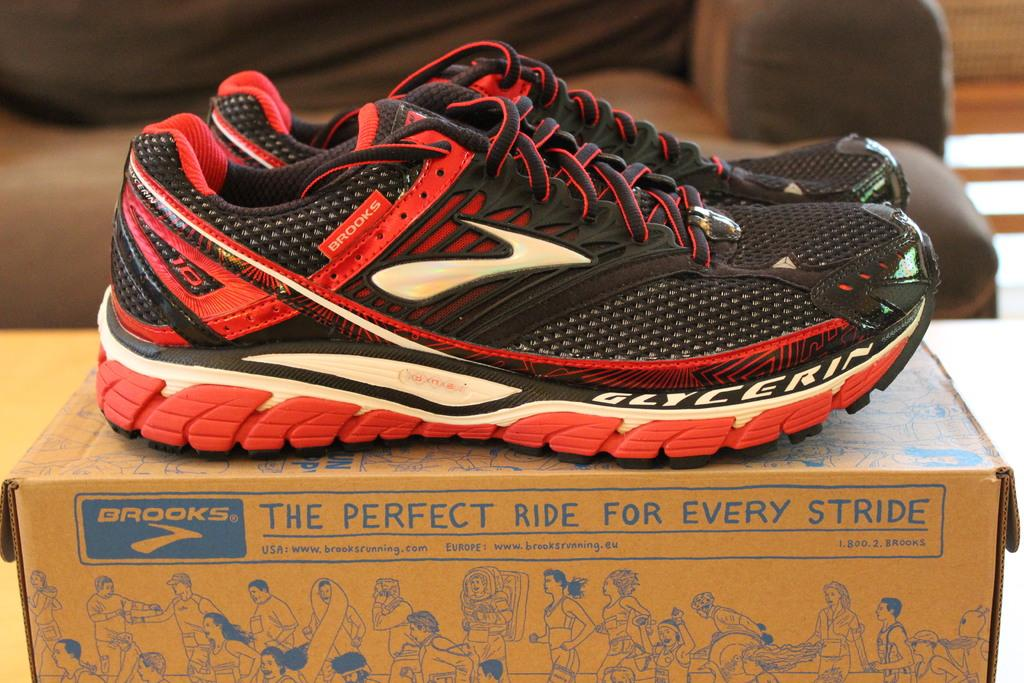What objects are in the image? There is a pair of shoes and a cardboard box in the image. Where are the shoes placed? The shoes are on a cardboard box. What is the cardboard box placed on? A: The cardboard box is on a table. What can be seen in the background of the image? There is a sofa in the background of the image. What type of chin is visible on the son in the image? There is no son or chin present in the image; it only features a pair of shoes on a cardboard box on a table with a sofa in the background. 